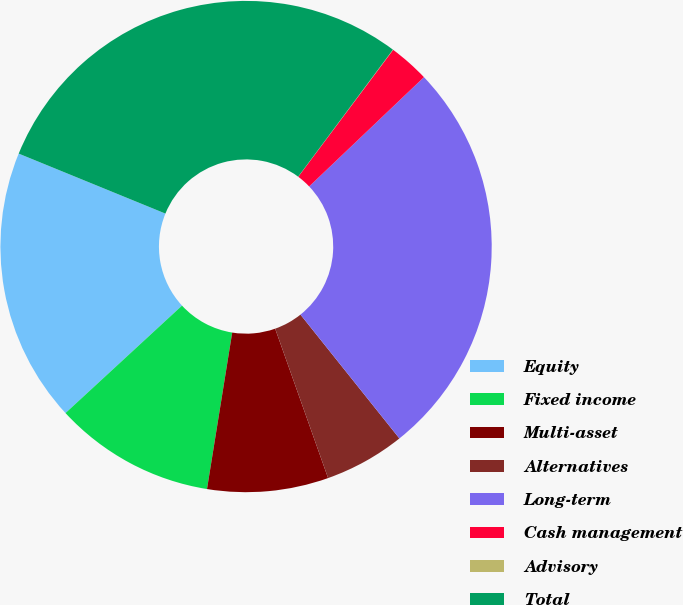Convert chart to OTSL. <chart><loc_0><loc_0><loc_500><loc_500><pie_chart><fcel>Equity<fcel>Fixed income<fcel>Multi-asset<fcel>Alternatives<fcel>Long-term<fcel>Cash management<fcel>Advisory<fcel>Total<nl><fcel>18.03%<fcel>10.6%<fcel>7.96%<fcel>5.31%<fcel>26.38%<fcel>2.67%<fcel>0.02%<fcel>29.02%<nl></chart> 